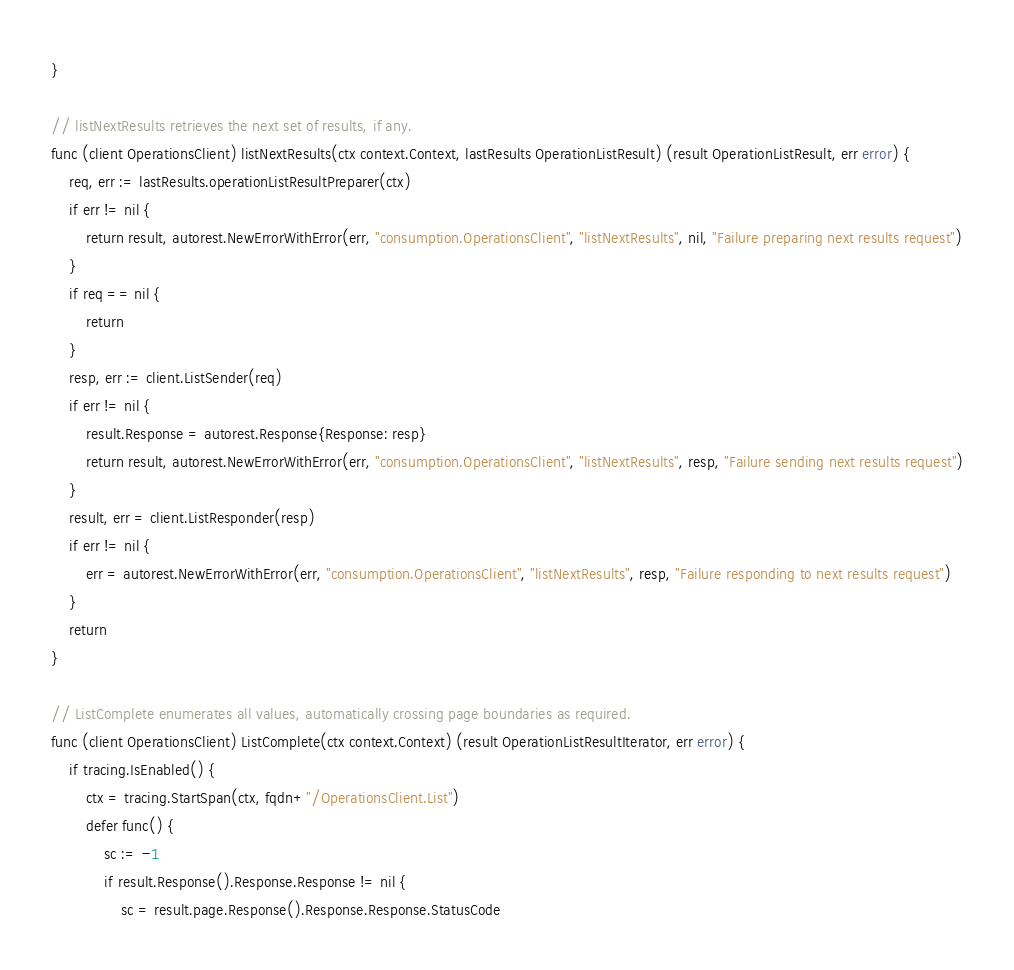Convert code to text. <code><loc_0><loc_0><loc_500><loc_500><_Go_>}

// listNextResults retrieves the next set of results, if any.
func (client OperationsClient) listNextResults(ctx context.Context, lastResults OperationListResult) (result OperationListResult, err error) {
	req, err := lastResults.operationListResultPreparer(ctx)
	if err != nil {
		return result, autorest.NewErrorWithError(err, "consumption.OperationsClient", "listNextResults", nil, "Failure preparing next results request")
	}
	if req == nil {
		return
	}
	resp, err := client.ListSender(req)
	if err != nil {
		result.Response = autorest.Response{Response: resp}
		return result, autorest.NewErrorWithError(err, "consumption.OperationsClient", "listNextResults", resp, "Failure sending next results request")
	}
	result, err = client.ListResponder(resp)
	if err != nil {
		err = autorest.NewErrorWithError(err, "consumption.OperationsClient", "listNextResults", resp, "Failure responding to next results request")
	}
	return
}

// ListComplete enumerates all values, automatically crossing page boundaries as required.
func (client OperationsClient) ListComplete(ctx context.Context) (result OperationListResultIterator, err error) {
	if tracing.IsEnabled() {
		ctx = tracing.StartSpan(ctx, fqdn+"/OperationsClient.List")
		defer func() {
			sc := -1
			if result.Response().Response.Response != nil {
				sc = result.page.Response().Response.Response.StatusCode</code> 